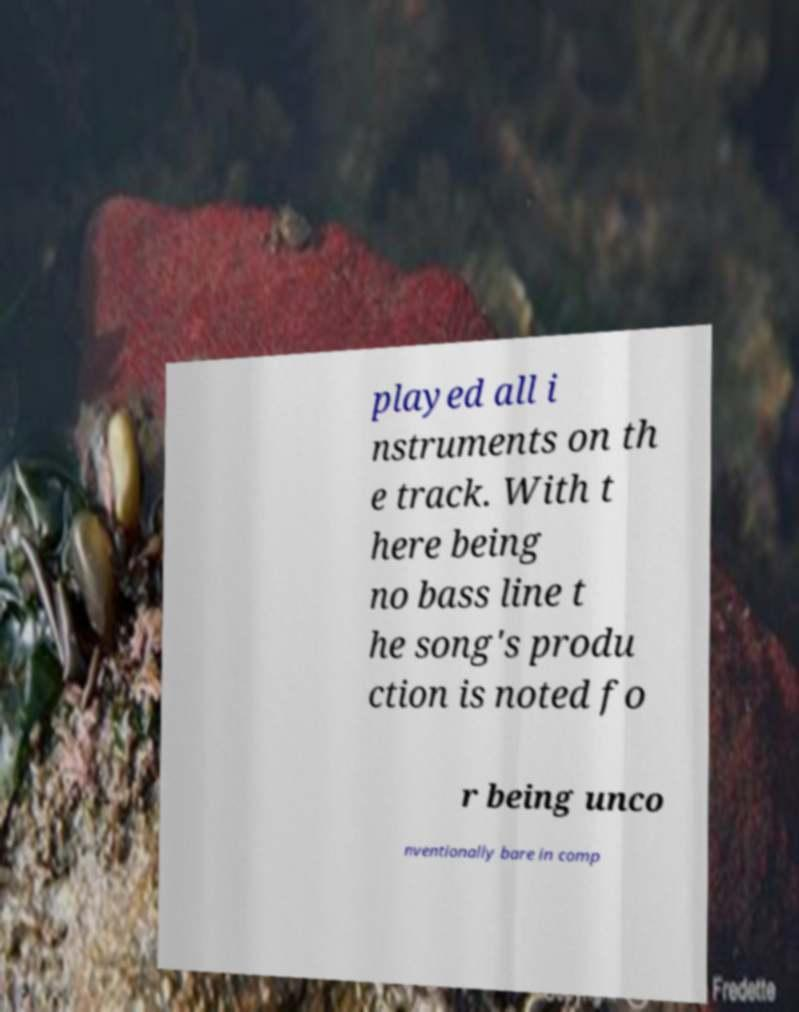Please read and relay the text visible in this image. What does it say? played all i nstruments on th e track. With t here being no bass line t he song's produ ction is noted fo r being unco nventionally bare in comp 